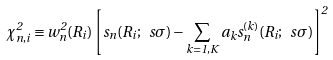<formula> <loc_0><loc_0><loc_500><loc_500>\chi ^ { 2 } _ { n , i } \equiv w ^ { 2 } _ { n } ( R _ { i } ) \left [ s _ { n } ( R _ { i } ; \ s \sigma ) - \sum _ { k = 1 , K } a _ { k } s _ { n } ^ { ( k ) } ( R _ { i } ; \ s \sigma ) \right ] ^ { 2 }</formula> 